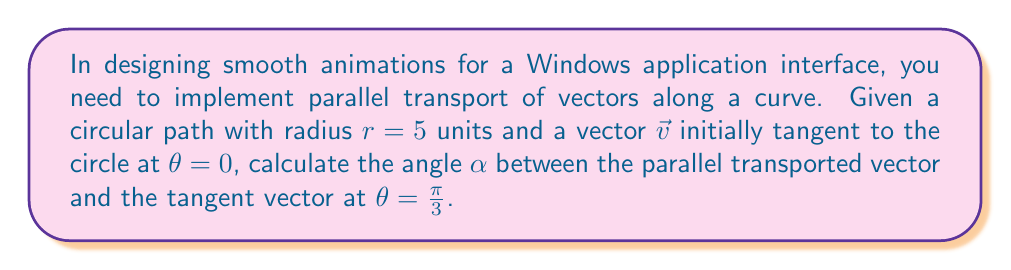Can you solve this math problem? To solve this problem, we'll follow these steps:

1) In parallel transport along a curve, the vector's magnitude and angle relative to the curve remain constant.

2) For a circle, the angle between a parallel transported vector and the tangent vector changes proportionally to the angle traversed along the circle.

3) The formula for this change is:
   $$\alpha = \theta \cdot \frac{\text{circumference} - r}{r}$$

   Where $\alpha$ is the angle between the parallel transported vector and the tangent vector, $\theta$ is the angle traversed along the circle, and $r$ is the radius.

4) We know:
   $r = 5$ units
   $\theta = \frac{\pi}{3}$

5) Calculate the circumference:
   $$\text{circumference} = 2\pi r = 2\pi \cdot 5 = 10\pi$$

6) Substitute into the formula:
   $$\alpha = \frac{\pi}{3} \cdot \frac{10\pi - 5}{5}$$

7) Simplify:
   $$\alpha = \frac{\pi}{3} \cdot (2\pi - 1) = \frac{2\pi^2}{3} - \frac{\pi}{3}$$

This angle $\alpha$ represents the rotation needed to smoothly animate the vector along the circular path in the user interface.
Answer: $\frac{2\pi^2}{3} - \frac{\pi}{3}$ radians 